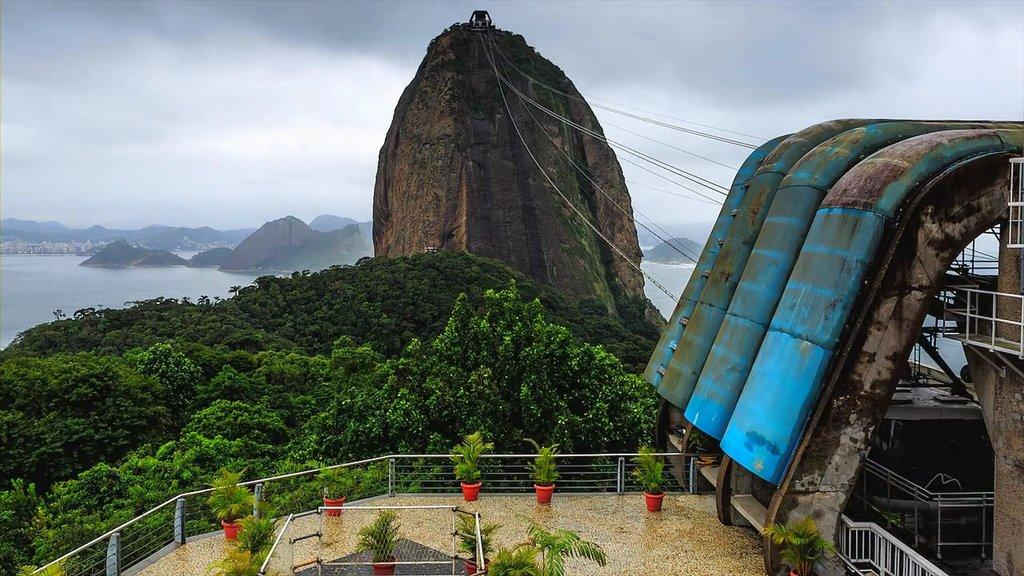What type of natural formation can be seen in the image? There are mountains in the image. What is the rock in the image used for? The fact does not specify the purpose of the rock, so we cannot determine its use from the image. What type of vegetation is present in the image? There are trees and flower pots visible in the image. What can be seen flowing or moving in the image? Water is visible in the image. What is the color of the sky in the image? The sky is visible in the image, but the color is not specified. How many cars are parked near the trees in the image? There are no cars present in the image; it features a rock, wires, trees, flower pots, water, mountains, and the sky. What type of pigs can be seen roaming around the flower pots in the image? There are no pigs present in the image. 